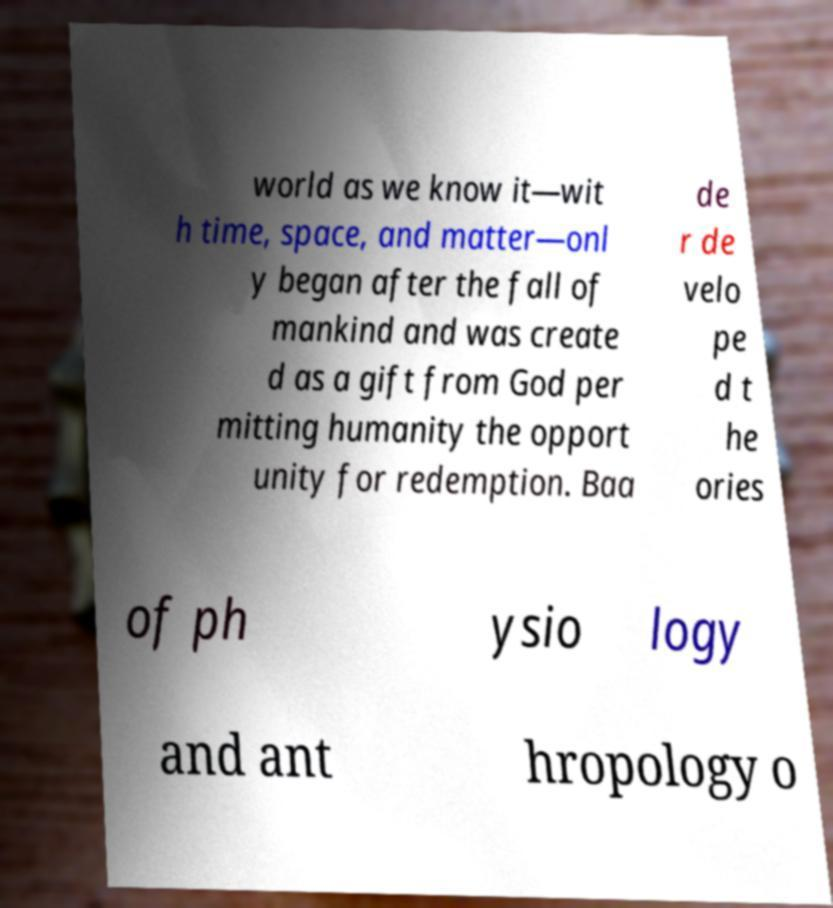Please identify and transcribe the text found in this image. world as we know it—wit h time, space, and matter—onl y began after the fall of mankind and was create d as a gift from God per mitting humanity the opport unity for redemption. Baa de r de velo pe d t he ories of ph ysio logy and ant hropology o 